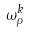<formula> <loc_0><loc_0><loc_500><loc_500>\omega _ { \rho } ^ { k }</formula> 